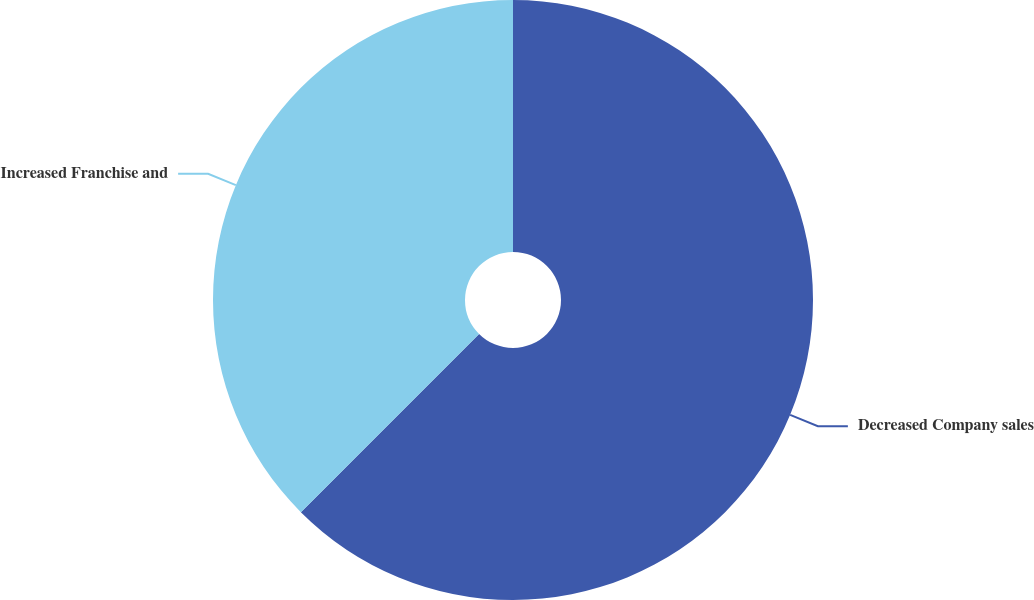Convert chart to OTSL. <chart><loc_0><loc_0><loc_500><loc_500><pie_chart><fcel>Decreased Company sales<fcel>Increased Franchise and<nl><fcel>62.5%<fcel>37.5%<nl></chart> 